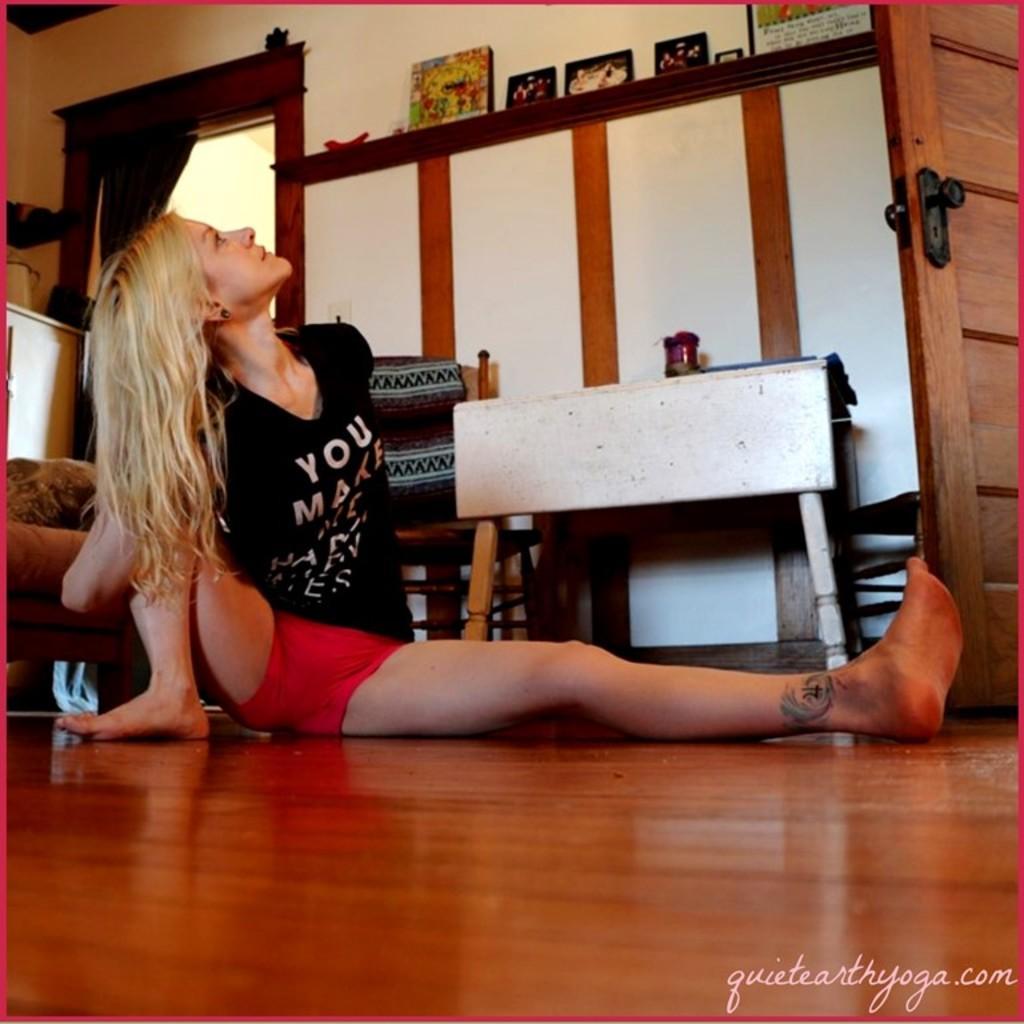Please provide a concise description of this image. There is a woman sitting on the floor, wearing a black t shirt. In the background there is a wall and some photo frames on the desk here. 